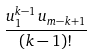Convert formula to latex. <formula><loc_0><loc_0><loc_500><loc_500>\frac { u _ { 1 } ^ { k - 1 } \, u _ { m - k + 1 } } { ( k - 1 ) ! }</formula> 